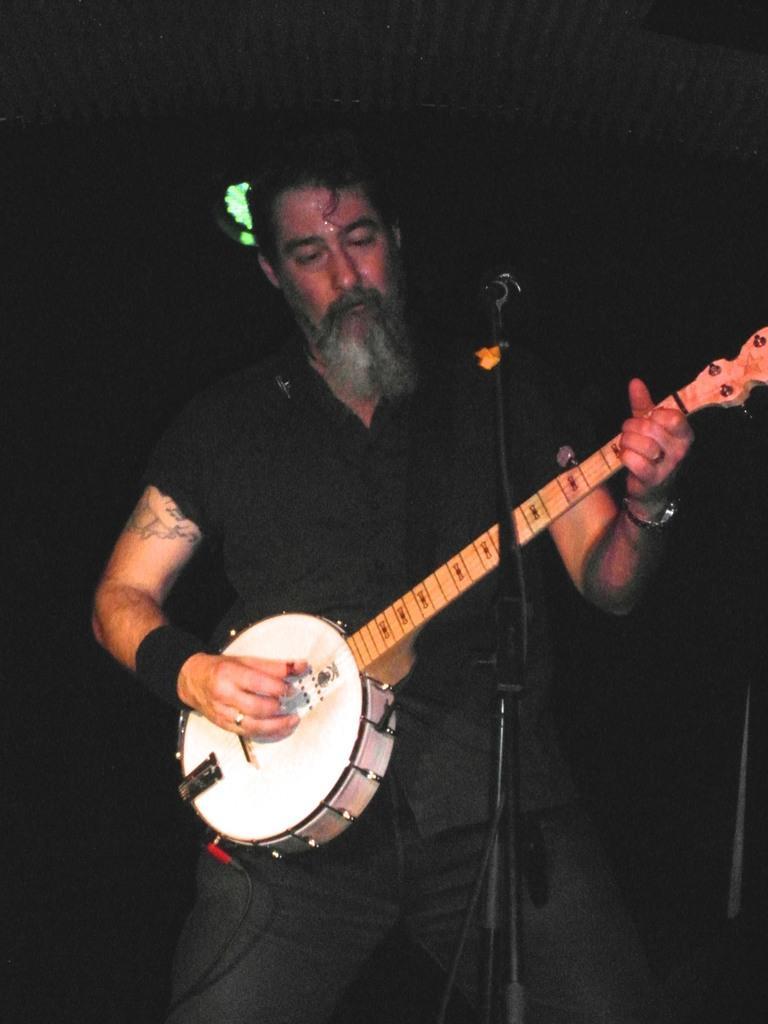Describe this image in one or two sentences. This person standing and playing musical instrument and wear black color shirt. There is a microphone with stand. On the background we can see focusing light. 